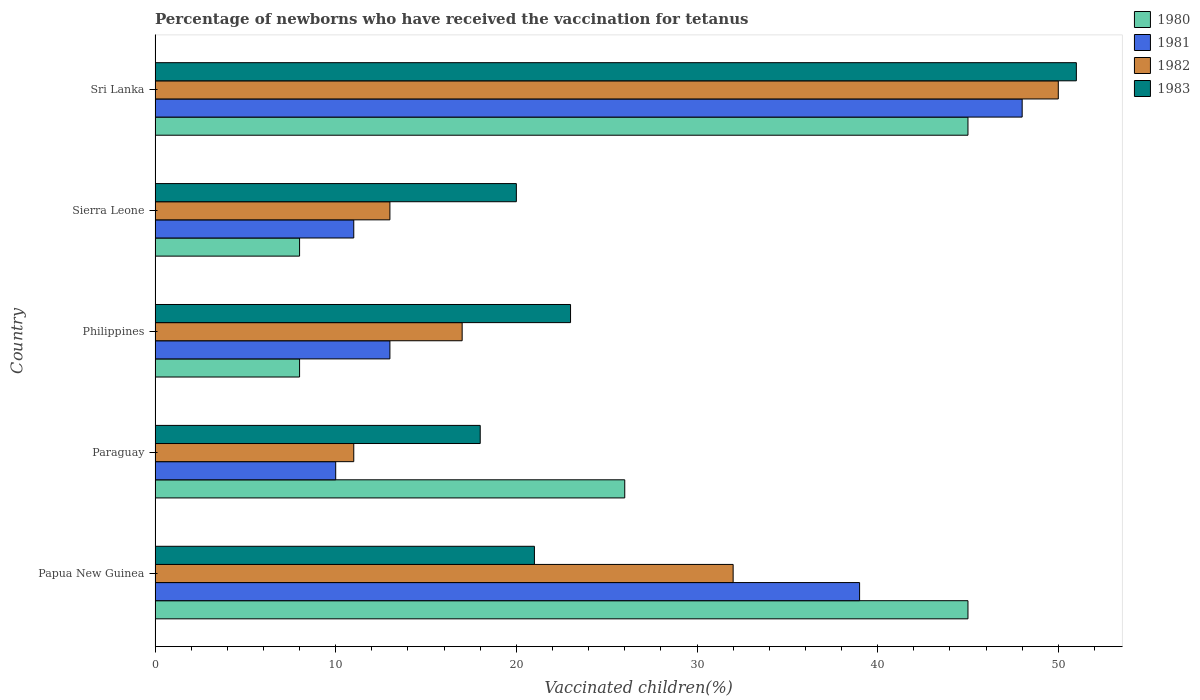How many groups of bars are there?
Your response must be concise. 5. How many bars are there on the 4th tick from the top?
Provide a short and direct response. 4. How many bars are there on the 1st tick from the bottom?
Your response must be concise. 4. Across all countries, what is the maximum percentage of vaccinated children in 1983?
Make the answer very short. 51. In which country was the percentage of vaccinated children in 1983 maximum?
Keep it short and to the point. Sri Lanka. In which country was the percentage of vaccinated children in 1981 minimum?
Your response must be concise. Paraguay. What is the total percentage of vaccinated children in 1983 in the graph?
Your answer should be compact. 133. What is the average percentage of vaccinated children in 1983 per country?
Offer a very short reply. 26.6. What is the ratio of the percentage of vaccinated children in 1981 in Paraguay to that in Sri Lanka?
Your answer should be compact. 0.21. Is the percentage of vaccinated children in 1983 in Paraguay less than that in Philippines?
Keep it short and to the point. Yes. What is the difference between the highest and the second highest percentage of vaccinated children in 1982?
Provide a short and direct response. 18. Is the sum of the percentage of vaccinated children in 1981 in Philippines and Sierra Leone greater than the maximum percentage of vaccinated children in 1983 across all countries?
Provide a short and direct response. No. Is it the case that in every country, the sum of the percentage of vaccinated children in 1980 and percentage of vaccinated children in 1981 is greater than the sum of percentage of vaccinated children in 1983 and percentage of vaccinated children in 1982?
Your answer should be very brief. No. What does the 4th bar from the bottom in Sri Lanka represents?
Keep it short and to the point. 1983. Does the graph contain grids?
Offer a very short reply. No. Where does the legend appear in the graph?
Give a very brief answer. Top right. What is the title of the graph?
Give a very brief answer. Percentage of newborns who have received the vaccination for tetanus. Does "1980" appear as one of the legend labels in the graph?
Keep it short and to the point. Yes. What is the label or title of the X-axis?
Your response must be concise. Vaccinated children(%). What is the label or title of the Y-axis?
Your response must be concise. Country. What is the Vaccinated children(%) of 1981 in Papua New Guinea?
Offer a terse response. 39. What is the Vaccinated children(%) of 1982 in Papua New Guinea?
Keep it short and to the point. 32. What is the Vaccinated children(%) in 1981 in Paraguay?
Your response must be concise. 10. What is the Vaccinated children(%) in 1982 in Paraguay?
Offer a terse response. 11. What is the Vaccinated children(%) in 1981 in Philippines?
Provide a succinct answer. 13. What is the Vaccinated children(%) in 1982 in Philippines?
Provide a succinct answer. 17. What is the Vaccinated children(%) of 1983 in Philippines?
Keep it short and to the point. 23. What is the Vaccinated children(%) in 1982 in Sierra Leone?
Your answer should be compact. 13. What is the Vaccinated children(%) in 1983 in Sierra Leone?
Give a very brief answer. 20. What is the Vaccinated children(%) of 1980 in Sri Lanka?
Make the answer very short. 45. What is the Vaccinated children(%) in 1981 in Sri Lanka?
Give a very brief answer. 48. Across all countries, what is the maximum Vaccinated children(%) of 1980?
Your answer should be compact. 45. Across all countries, what is the maximum Vaccinated children(%) in 1981?
Provide a short and direct response. 48. Across all countries, what is the maximum Vaccinated children(%) of 1982?
Make the answer very short. 50. Across all countries, what is the maximum Vaccinated children(%) in 1983?
Offer a terse response. 51. Across all countries, what is the minimum Vaccinated children(%) of 1981?
Make the answer very short. 10. Across all countries, what is the minimum Vaccinated children(%) of 1982?
Make the answer very short. 11. What is the total Vaccinated children(%) of 1980 in the graph?
Your answer should be very brief. 132. What is the total Vaccinated children(%) in 1981 in the graph?
Your answer should be compact. 121. What is the total Vaccinated children(%) in 1982 in the graph?
Your response must be concise. 123. What is the total Vaccinated children(%) in 1983 in the graph?
Offer a very short reply. 133. What is the difference between the Vaccinated children(%) in 1980 in Papua New Guinea and that in Paraguay?
Offer a terse response. 19. What is the difference between the Vaccinated children(%) of 1981 in Papua New Guinea and that in Paraguay?
Offer a terse response. 29. What is the difference between the Vaccinated children(%) in 1982 in Papua New Guinea and that in Paraguay?
Provide a short and direct response. 21. What is the difference between the Vaccinated children(%) in 1982 in Papua New Guinea and that in Philippines?
Your answer should be compact. 15. What is the difference between the Vaccinated children(%) of 1980 in Papua New Guinea and that in Sierra Leone?
Provide a succinct answer. 37. What is the difference between the Vaccinated children(%) in 1981 in Papua New Guinea and that in Sierra Leone?
Your answer should be compact. 28. What is the difference between the Vaccinated children(%) in 1982 in Papua New Guinea and that in Sierra Leone?
Give a very brief answer. 19. What is the difference between the Vaccinated children(%) of 1980 in Papua New Guinea and that in Sri Lanka?
Your response must be concise. 0. What is the difference between the Vaccinated children(%) of 1982 in Papua New Guinea and that in Sri Lanka?
Ensure brevity in your answer.  -18. What is the difference between the Vaccinated children(%) in 1982 in Paraguay and that in Philippines?
Your response must be concise. -6. What is the difference between the Vaccinated children(%) of 1980 in Paraguay and that in Sierra Leone?
Your response must be concise. 18. What is the difference between the Vaccinated children(%) in 1982 in Paraguay and that in Sierra Leone?
Your answer should be very brief. -2. What is the difference between the Vaccinated children(%) of 1983 in Paraguay and that in Sierra Leone?
Make the answer very short. -2. What is the difference between the Vaccinated children(%) in 1980 in Paraguay and that in Sri Lanka?
Give a very brief answer. -19. What is the difference between the Vaccinated children(%) in 1981 in Paraguay and that in Sri Lanka?
Ensure brevity in your answer.  -38. What is the difference between the Vaccinated children(%) of 1982 in Paraguay and that in Sri Lanka?
Give a very brief answer. -39. What is the difference between the Vaccinated children(%) in 1983 in Paraguay and that in Sri Lanka?
Provide a short and direct response. -33. What is the difference between the Vaccinated children(%) in 1983 in Philippines and that in Sierra Leone?
Provide a succinct answer. 3. What is the difference between the Vaccinated children(%) of 1980 in Philippines and that in Sri Lanka?
Provide a succinct answer. -37. What is the difference between the Vaccinated children(%) in 1981 in Philippines and that in Sri Lanka?
Ensure brevity in your answer.  -35. What is the difference between the Vaccinated children(%) of 1982 in Philippines and that in Sri Lanka?
Your answer should be compact. -33. What is the difference between the Vaccinated children(%) of 1983 in Philippines and that in Sri Lanka?
Make the answer very short. -28. What is the difference between the Vaccinated children(%) of 1980 in Sierra Leone and that in Sri Lanka?
Your response must be concise. -37. What is the difference between the Vaccinated children(%) in 1981 in Sierra Leone and that in Sri Lanka?
Ensure brevity in your answer.  -37. What is the difference between the Vaccinated children(%) in 1982 in Sierra Leone and that in Sri Lanka?
Ensure brevity in your answer.  -37. What is the difference between the Vaccinated children(%) in 1983 in Sierra Leone and that in Sri Lanka?
Your answer should be compact. -31. What is the difference between the Vaccinated children(%) in 1980 in Papua New Guinea and the Vaccinated children(%) in 1981 in Paraguay?
Ensure brevity in your answer.  35. What is the difference between the Vaccinated children(%) of 1980 in Papua New Guinea and the Vaccinated children(%) of 1983 in Paraguay?
Keep it short and to the point. 27. What is the difference between the Vaccinated children(%) in 1981 in Papua New Guinea and the Vaccinated children(%) in 1982 in Paraguay?
Offer a very short reply. 28. What is the difference between the Vaccinated children(%) in 1981 in Papua New Guinea and the Vaccinated children(%) in 1983 in Paraguay?
Make the answer very short. 21. What is the difference between the Vaccinated children(%) of 1980 in Papua New Guinea and the Vaccinated children(%) of 1983 in Philippines?
Your answer should be very brief. 22. What is the difference between the Vaccinated children(%) in 1981 in Papua New Guinea and the Vaccinated children(%) in 1983 in Philippines?
Give a very brief answer. 16. What is the difference between the Vaccinated children(%) in 1981 in Papua New Guinea and the Vaccinated children(%) in 1982 in Sierra Leone?
Ensure brevity in your answer.  26. What is the difference between the Vaccinated children(%) in 1981 in Papua New Guinea and the Vaccinated children(%) in 1983 in Sierra Leone?
Provide a succinct answer. 19. What is the difference between the Vaccinated children(%) of 1980 in Papua New Guinea and the Vaccinated children(%) of 1982 in Sri Lanka?
Ensure brevity in your answer.  -5. What is the difference between the Vaccinated children(%) in 1980 in Papua New Guinea and the Vaccinated children(%) in 1983 in Sri Lanka?
Keep it short and to the point. -6. What is the difference between the Vaccinated children(%) in 1981 in Papua New Guinea and the Vaccinated children(%) in 1982 in Sri Lanka?
Offer a terse response. -11. What is the difference between the Vaccinated children(%) in 1982 in Papua New Guinea and the Vaccinated children(%) in 1983 in Sri Lanka?
Provide a short and direct response. -19. What is the difference between the Vaccinated children(%) of 1980 in Paraguay and the Vaccinated children(%) of 1981 in Philippines?
Provide a succinct answer. 13. What is the difference between the Vaccinated children(%) in 1980 in Paraguay and the Vaccinated children(%) in 1981 in Sierra Leone?
Your response must be concise. 15. What is the difference between the Vaccinated children(%) of 1981 in Paraguay and the Vaccinated children(%) of 1982 in Sierra Leone?
Give a very brief answer. -3. What is the difference between the Vaccinated children(%) of 1981 in Paraguay and the Vaccinated children(%) of 1983 in Sierra Leone?
Your response must be concise. -10. What is the difference between the Vaccinated children(%) in 1982 in Paraguay and the Vaccinated children(%) in 1983 in Sierra Leone?
Your answer should be very brief. -9. What is the difference between the Vaccinated children(%) of 1981 in Paraguay and the Vaccinated children(%) of 1983 in Sri Lanka?
Offer a very short reply. -41. What is the difference between the Vaccinated children(%) of 1980 in Philippines and the Vaccinated children(%) of 1982 in Sierra Leone?
Give a very brief answer. -5. What is the difference between the Vaccinated children(%) of 1980 in Philippines and the Vaccinated children(%) of 1983 in Sierra Leone?
Provide a short and direct response. -12. What is the difference between the Vaccinated children(%) of 1981 in Philippines and the Vaccinated children(%) of 1982 in Sierra Leone?
Keep it short and to the point. 0. What is the difference between the Vaccinated children(%) of 1980 in Philippines and the Vaccinated children(%) of 1982 in Sri Lanka?
Your answer should be compact. -42. What is the difference between the Vaccinated children(%) of 1980 in Philippines and the Vaccinated children(%) of 1983 in Sri Lanka?
Provide a short and direct response. -43. What is the difference between the Vaccinated children(%) of 1981 in Philippines and the Vaccinated children(%) of 1982 in Sri Lanka?
Provide a succinct answer. -37. What is the difference between the Vaccinated children(%) of 1981 in Philippines and the Vaccinated children(%) of 1983 in Sri Lanka?
Keep it short and to the point. -38. What is the difference between the Vaccinated children(%) in 1982 in Philippines and the Vaccinated children(%) in 1983 in Sri Lanka?
Provide a short and direct response. -34. What is the difference between the Vaccinated children(%) in 1980 in Sierra Leone and the Vaccinated children(%) in 1982 in Sri Lanka?
Keep it short and to the point. -42. What is the difference between the Vaccinated children(%) in 1980 in Sierra Leone and the Vaccinated children(%) in 1983 in Sri Lanka?
Offer a very short reply. -43. What is the difference between the Vaccinated children(%) in 1981 in Sierra Leone and the Vaccinated children(%) in 1982 in Sri Lanka?
Your answer should be very brief. -39. What is the difference between the Vaccinated children(%) of 1982 in Sierra Leone and the Vaccinated children(%) of 1983 in Sri Lanka?
Offer a terse response. -38. What is the average Vaccinated children(%) in 1980 per country?
Your answer should be compact. 26.4. What is the average Vaccinated children(%) in 1981 per country?
Your response must be concise. 24.2. What is the average Vaccinated children(%) in 1982 per country?
Give a very brief answer. 24.6. What is the average Vaccinated children(%) in 1983 per country?
Provide a short and direct response. 26.6. What is the difference between the Vaccinated children(%) in 1980 and Vaccinated children(%) in 1983 in Papua New Guinea?
Offer a terse response. 24. What is the difference between the Vaccinated children(%) of 1981 and Vaccinated children(%) of 1982 in Papua New Guinea?
Give a very brief answer. 7. What is the difference between the Vaccinated children(%) of 1981 and Vaccinated children(%) of 1983 in Papua New Guinea?
Give a very brief answer. 18. What is the difference between the Vaccinated children(%) in 1982 and Vaccinated children(%) in 1983 in Papua New Guinea?
Your answer should be very brief. 11. What is the difference between the Vaccinated children(%) of 1980 and Vaccinated children(%) of 1981 in Paraguay?
Ensure brevity in your answer.  16. What is the difference between the Vaccinated children(%) of 1980 and Vaccinated children(%) of 1982 in Paraguay?
Keep it short and to the point. 15. What is the difference between the Vaccinated children(%) of 1980 and Vaccinated children(%) of 1983 in Paraguay?
Give a very brief answer. 8. What is the difference between the Vaccinated children(%) in 1981 and Vaccinated children(%) in 1983 in Paraguay?
Offer a terse response. -8. What is the difference between the Vaccinated children(%) in 1980 and Vaccinated children(%) in 1982 in Philippines?
Offer a very short reply. -9. What is the difference between the Vaccinated children(%) of 1981 and Vaccinated children(%) of 1982 in Philippines?
Your answer should be compact. -4. What is the difference between the Vaccinated children(%) of 1981 and Vaccinated children(%) of 1983 in Philippines?
Ensure brevity in your answer.  -10. What is the difference between the Vaccinated children(%) of 1980 and Vaccinated children(%) of 1981 in Sierra Leone?
Offer a very short reply. -3. What is the difference between the Vaccinated children(%) in 1980 and Vaccinated children(%) in 1983 in Sierra Leone?
Provide a succinct answer. -12. What is the difference between the Vaccinated children(%) of 1981 and Vaccinated children(%) of 1982 in Sierra Leone?
Your answer should be compact. -2. What is the difference between the Vaccinated children(%) of 1981 and Vaccinated children(%) of 1983 in Sierra Leone?
Offer a terse response. -9. What is the difference between the Vaccinated children(%) in 1980 and Vaccinated children(%) in 1981 in Sri Lanka?
Provide a short and direct response. -3. What is the difference between the Vaccinated children(%) in 1980 and Vaccinated children(%) in 1983 in Sri Lanka?
Give a very brief answer. -6. What is the ratio of the Vaccinated children(%) in 1980 in Papua New Guinea to that in Paraguay?
Keep it short and to the point. 1.73. What is the ratio of the Vaccinated children(%) in 1981 in Papua New Guinea to that in Paraguay?
Your answer should be compact. 3.9. What is the ratio of the Vaccinated children(%) of 1982 in Papua New Guinea to that in Paraguay?
Your answer should be very brief. 2.91. What is the ratio of the Vaccinated children(%) of 1980 in Papua New Guinea to that in Philippines?
Ensure brevity in your answer.  5.62. What is the ratio of the Vaccinated children(%) of 1981 in Papua New Guinea to that in Philippines?
Make the answer very short. 3. What is the ratio of the Vaccinated children(%) of 1982 in Papua New Guinea to that in Philippines?
Provide a short and direct response. 1.88. What is the ratio of the Vaccinated children(%) of 1983 in Papua New Guinea to that in Philippines?
Keep it short and to the point. 0.91. What is the ratio of the Vaccinated children(%) in 1980 in Papua New Guinea to that in Sierra Leone?
Provide a short and direct response. 5.62. What is the ratio of the Vaccinated children(%) in 1981 in Papua New Guinea to that in Sierra Leone?
Provide a short and direct response. 3.55. What is the ratio of the Vaccinated children(%) in 1982 in Papua New Guinea to that in Sierra Leone?
Provide a short and direct response. 2.46. What is the ratio of the Vaccinated children(%) of 1983 in Papua New Guinea to that in Sierra Leone?
Provide a succinct answer. 1.05. What is the ratio of the Vaccinated children(%) in 1981 in Papua New Guinea to that in Sri Lanka?
Your response must be concise. 0.81. What is the ratio of the Vaccinated children(%) in 1982 in Papua New Guinea to that in Sri Lanka?
Your answer should be very brief. 0.64. What is the ratio of the Vaccinated children(%) in 1983 in Papua New Guinea to that in Sri Lanka?
Give a very brief answer. 0.41. What is the ratio of the Vaccinated children(%) in 1981 in Paraguay to that in Philippines?
Offer a terse response. 0.77. What is the ratio of the Vaccinated children(%) in 1982 in Paraguay to that in Philippines?
Keep it short and to the point. 0.65. What is the ratio of the Vaccinated children(%) of 1983 in Paraguay to that in Philippines?
Offer a terse response. 0.78. What is the ratio of the Vaccinated children(%) in 1982 in Paraguay to that in Sierra Leone?
Offer a terse response. 0.85. What is the ratio of the Vaccinated children(%) in 1980 in Paraguay to that in Sri Lanka?
Give a very brief answer. 0.58. What is the ratio of the Vaccinated children(%) in 1981 in Paraguay to that in Sri Lanka?
Ensure brevity in your answer.  0.21. What is the ratio of the Vaccinated children(%) of 1982 in Paraguay to that in Sri Lanka?
Give a very brief answer. 0.22. What is the ratio of the Vaccinated children(%) of 1983 in Paraguay to that in Sri Lanka?
Make the answer very short. 0.35. What is the ratio of the Vaccinated children(%) in 1980 in Philippines to that in Sierra Leone?
Your answer should be compact. 1. What is the ratio of the Vaccinated children(%) in 1981 in Philippines to that in Sierra Leone?
Your answer should be compact. 1.18. What is the ratio of the Vaccinated children(%) in 1982 in Philippines to that in Sierra Leone?
Your answer should be very brief. 1.31. What is the ratio of the Vaccinated children(%) of 1983 in Philippines to that in Sierra Leone?
Keep it short and to the point. 1.15. What is the ratio of the Vaccinated children(%) in 1980 in Philippines to that in Sri Lanka?
Ensure brevity in your answer.  0.18. What is the ratio of the Vaccinated children(%) of 1981 in Philippines to that in Sri Lanka?
Provide a short and direct response. 0.27. What is the ratio of the Vaccinated children(%) in 1982 in Philippines to that in Sri Lanka?
Provide a succinct answer. 0.34. What is the ratio of the Vaccinated children(%) of 1983 in Philippines to that in Sri Lanka?
Provide a succinct answer. 0.45. What is the ratio of the Vaccinated children(%) of 1980 in Sierra Leone to that in Sri Lanka?
Provide a short and direct response. 0.18. What is the ratio of the Vaccinated children(%) of 1981 in Sierra Leone to that in Sri Lanka?
Offer a terse response. 0.23. What is the ratio of the Vaccinated children(%) in 1982 in Sierra Leone to that in Sri Lanka?
Give a very brief answer. 0.26. What is the ratio of the Vaccinated children(%) of 1983 in Sierra Leone to that in Sri Lanka?
Give a very brief answer. 0.39. What is the difference between the highest and the second highest Vaccinated children(%) in 1981?
Your answer should be very brief. 9. What is the difference between the highest and the second highest Vaccinated children(%) in 1982?
Provide a short and direct response. 18. What is the difference between the highest and the second highest Vaccinated children(%) in 1983?
Your response must be concise. 28. What is the difference between the highest and the lowest Vaccinated children(%) of 1983?
Provide a succinct answer. 33. 